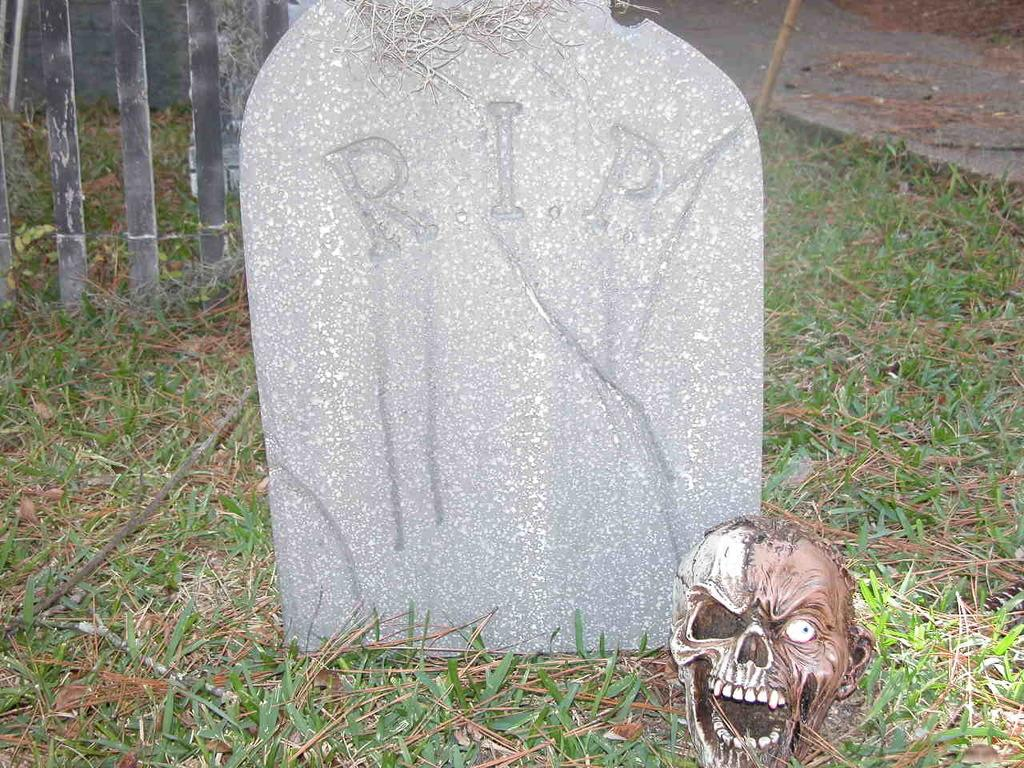What is located on the grass in the image? There is a skeleton on the grass. What is the skeleton's proximity to in the image? The skeleton is near a grave. What can be seen in the background of the image? There is fencing and a road in the background. What type of verse is being recited by the skeleton in the image? There is no indication in the image that the skeleton is reciting any verse, as it is a static image of a skeleton on the grass. 